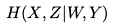Convert formula to latex. <formula><loc_0><loc_0><loc_500><loc_500>H ( X , Z | W , Y )</formula> 